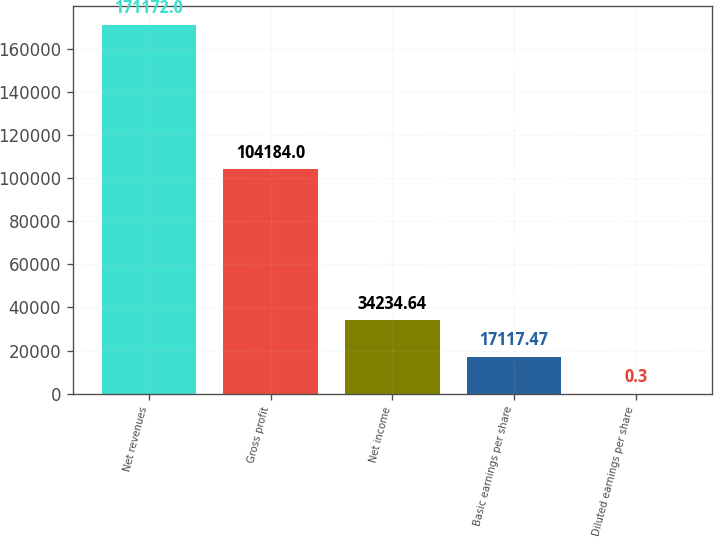Convert chart to OTSL. <chart><loc_0><loc_0><loc_500><loc_500><bar_chart><fcel>Net revenues<fcel>Gross profit<fcel>Net income<fcel>Basic earnings per share<fcel>Diluted earnings per share<nl><fcel>171172<fcel>104184<fcel>34234.6<fcel>17117.5<fcel>0.3<nl></chart> 